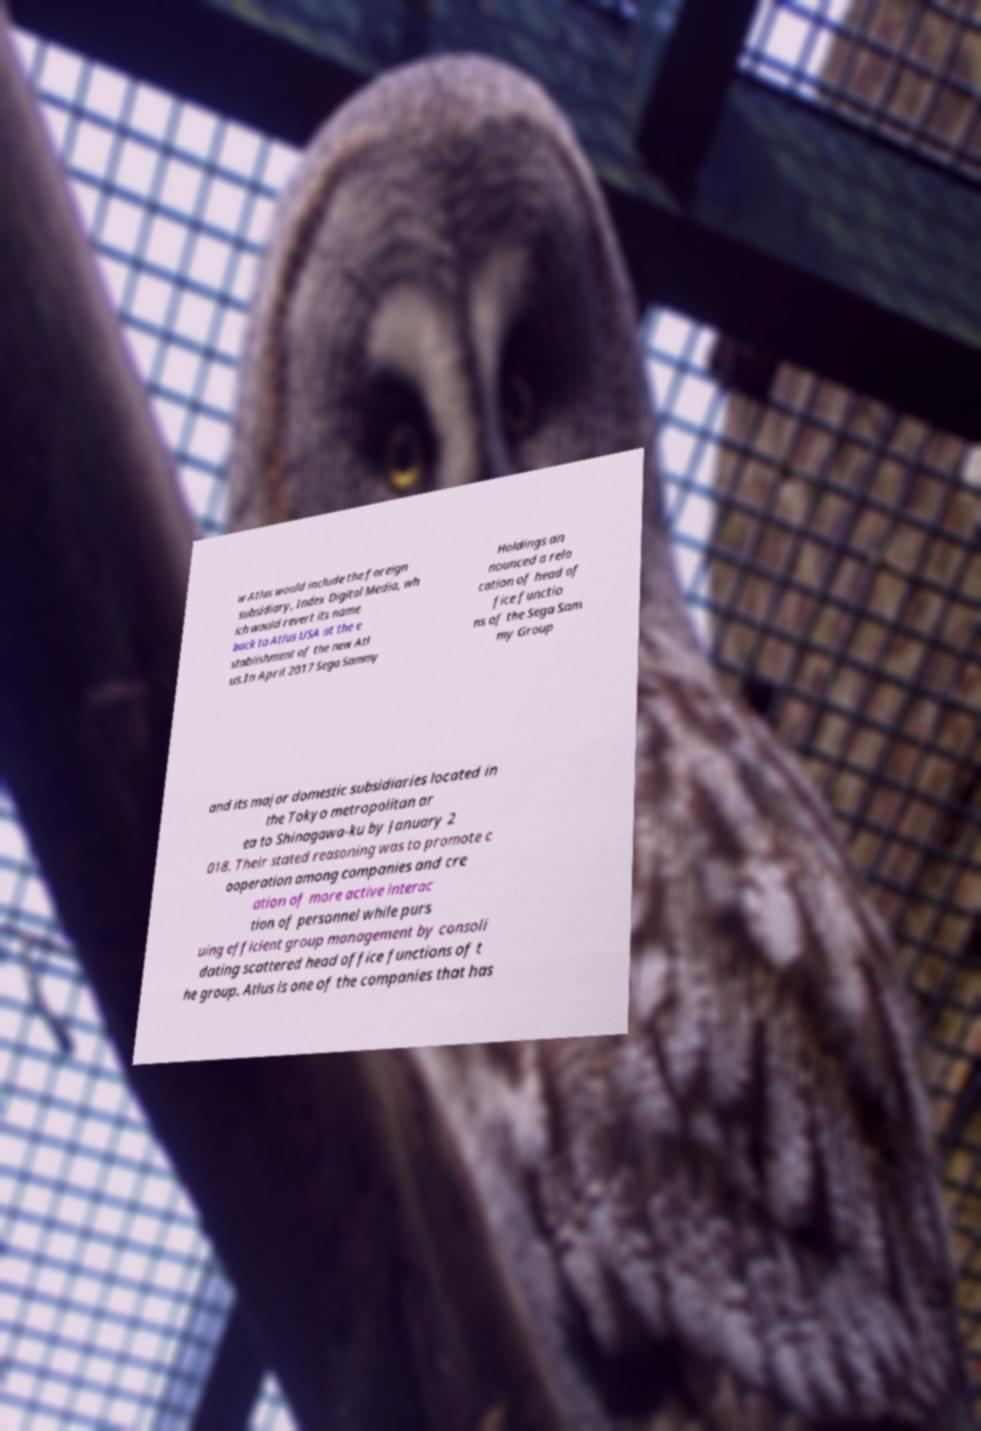For documentation purposes, I need the text within this image transcribed. Could you provide that? w Atlus would include the foreign subsidiary, Index Digital Media, wh ich would revert its name back to Atlus USA at the e stablishment of the new Atl us.In April 2017 Sega Sammy Holdings an nounced a relo cation of head of fice functio ns of the Sega Sam my Group and its major domestic subsidiaries located in the Tokyo metropolitan ar ea to Shinagawa-ku by January 2 018. Their stated reasoning was to promote c ooperation among companies and cre ation of more active interac tion of personnel while purs uing efficient group management by consoli dating scattered head office functions of t he group. Atlus is one of the companies that has 